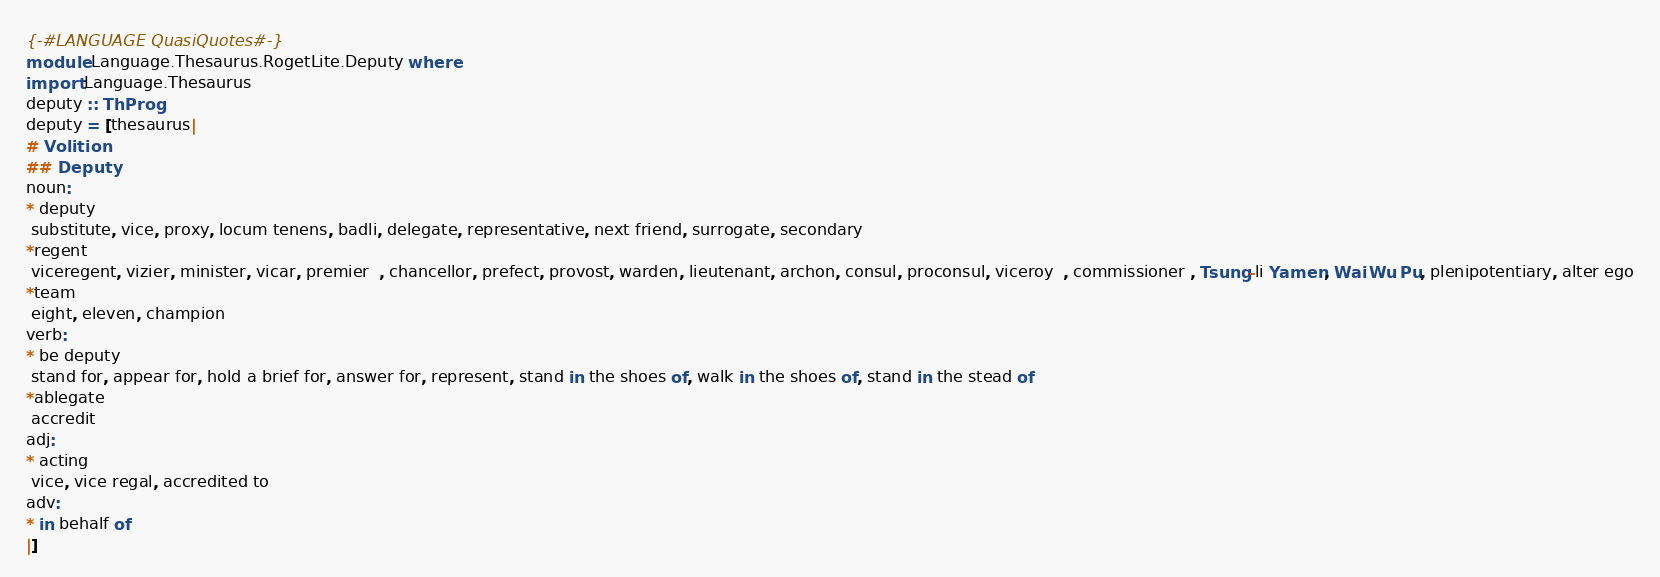Convert code to text. <code><loc_0><loc_0><loc_500><loc_500><_Haskell_>{-#LANGUAGE QuasiQuotes#-}
module Language.Thesaurus.RogetLite.Deputy where 
import Language.Thesaurus
deputy :: ThProg
deputy = [thesaurus|
# Volition
## Deputy
noun:
* deputy
 substitute, vice, proxy, locum tenens, badli, delegate, representative, next friend, surrogate, secondary
*regent
 viceregent, vizier, minister, vicar, premier  , chancellor, prefect, provost, warden, lieutenant, archon, consul, proconsul, viceroy  , commissioner , Tsung-li Yamen, Wai Wu Pu, plenipotentiary, alter ego
*team
 eight, eleven, champion
verb:
* be deputy
 stand for, appear for, hold a brief for, answer for, represent, stand in the shoes of, walk in the shoes of, stand in the stead of
*ablegate
 accredit
adj:
* acting
 vice, vice regal, accredited to
adv:
* in behalf of
|]
</code> 